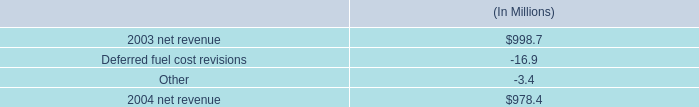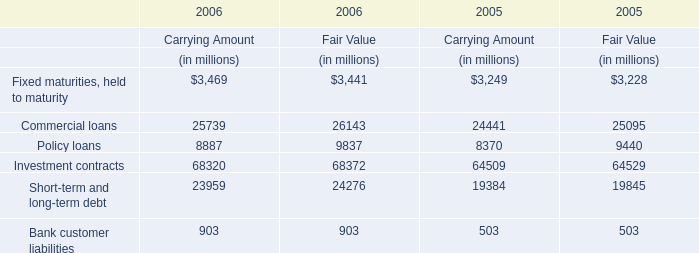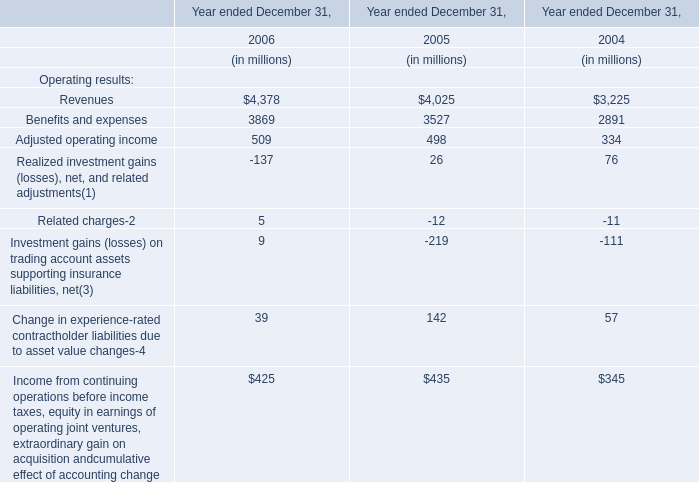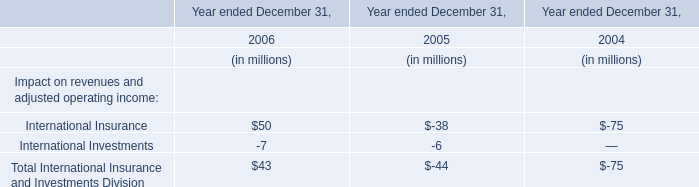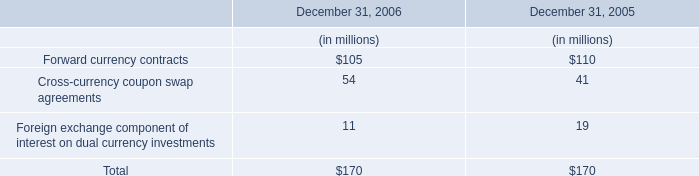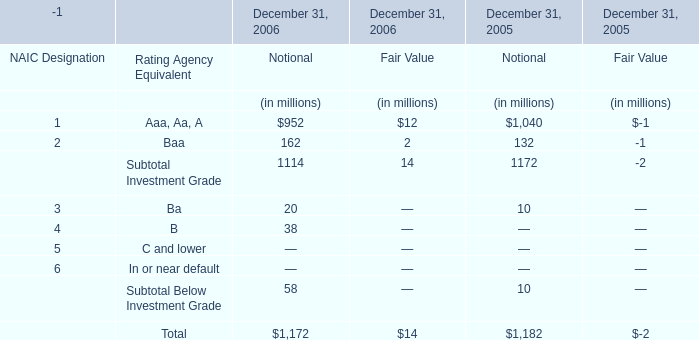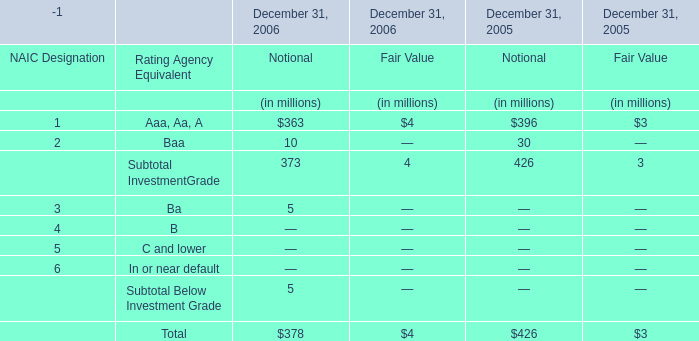In which year is Aaa, Aa, A for Notional positive? 
Answer: 2005,2006. 